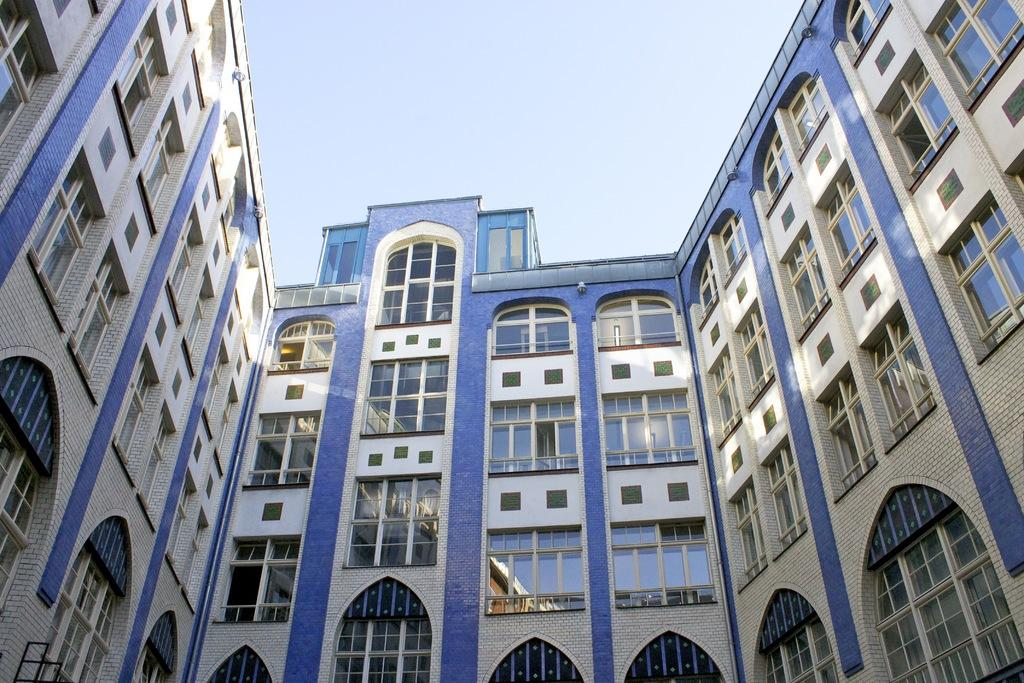What type of structures are present in the image? There are buildings in the image. What feature can be seen on the buildings? The buildings have windows. What can be seen in the background of the image? The sky is visible in the background of the image. What type of copper material is used to construct the buildings in the image? There is no mention of copper being used in the construction of the buildings in the image. 